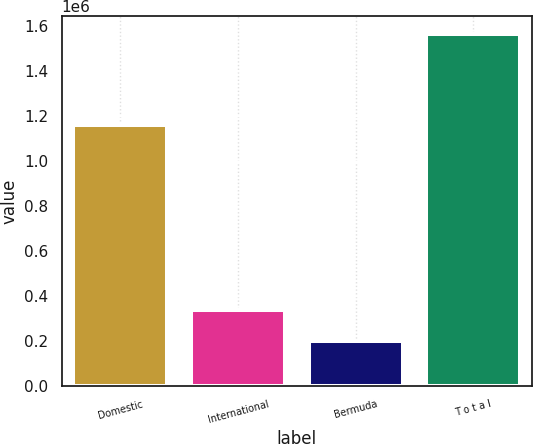Convert chart. <chart><loc_0><loc_0><loc_500><loc_500><bar_chart><fcel>Domestic<fcel>International<fcel>Bermuda<fcel>T o t a l<nl><fcel>1.15941e+06<fcel>335812<fcel>199002<fcel>1.5671e+06<nl></chart> 